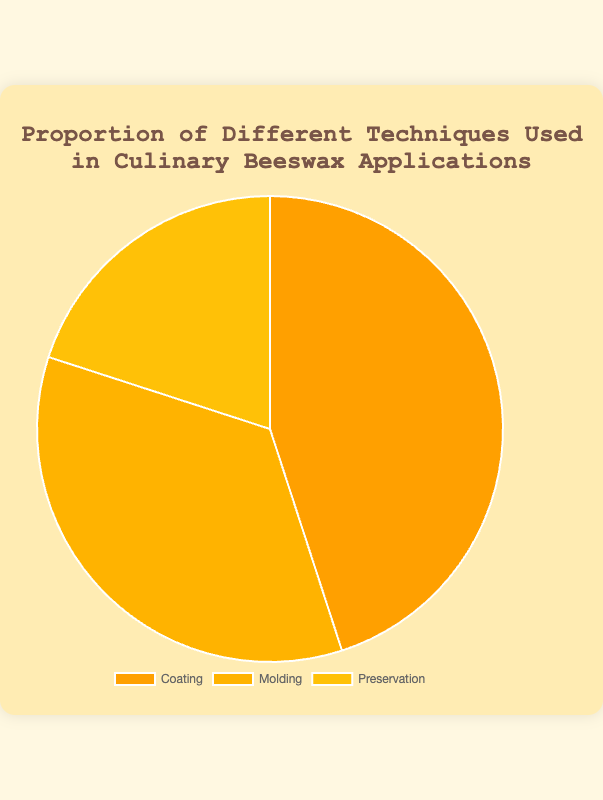What percentage of techniques involve either Molding or Preservation? To solve this, add the proportions of Molding and Preservation: 35% (Molding) + 20% (Preservation) = 55%.
Answer: 55% Which technique has the highest proportion? The technique with the highest proportion is displayed as the largest slice in the pie chart. Coating, with a proportion of 45%, is the highest.
Answer: Coating What’s the difference in percentage between the Coating and Preservation techniques? Subtract the proportion of Preservation from the proportion of Coating: 45% (Coating) - 20% (Preservation) = 25%.
Answer: 25% What proportion of techniques does not involve Coating? To find this, subtract the proportion of Coating from 100%: 100% - 45% (Coating) = 55%.
Answer: 55% Which technique is represented by the smallest slice in the pie chart? The smallest slice in the pie chart corresponds to the technique with the lowest proportion, which is Preservation at 20%.
Answer: Preservation How much more is the proportion of Molding compared to Preservation? Subtract the proportion of Preservation from the proportion of Molding: 35% (Molding) - 20% (Preservation) = 15%.
Answer: 15% Between Coating and Molding, which technique has a higher proportion and by how much? Coating has a higher proportion compared to Molding. The difference is calculated as 45% (Coating) - 35% (Molding) = 10%.
Answer: Coating by 10% What are the combined proportions for Coating and Preservation? Add the proportions of Coating and Preservation: 45% (Coating) + 20% (Preservation) = 65%.
Answer: 65% What is the average proportion of the three techniques? To calculate the average, add up all the proportions and divide by the number of techniques: (45% + 35% + 20%) / 3 = 100% / 3 ≈ 33.33%.
Answer: Approximately 33.33% What is the total proportion represented in the pie chart? The total proportion is the sum of all the proportions, which equals 100% since it's a pie chart.
Answer: 100% 